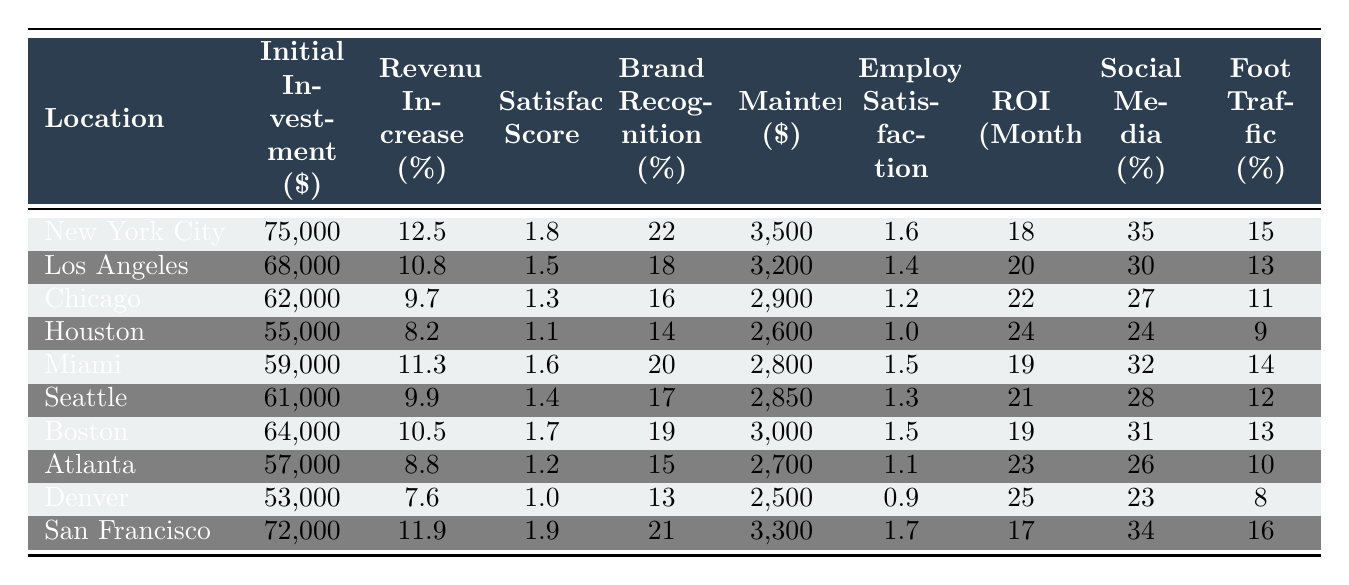What is the initial investment for the store in Miami? The initial investment for Miami is listed directly in the table under the "Initial Investment ($)" column. The value for Miami is 59,000.
Answer: 59,000 Which store location has the highest brand recognition boost percentage? The "Brand Recognition Boost (%)" column shows the percentage boosts for each location. Scanning through the values, San Francisco has the highest at 21%.
Answer: 21% What is the ROI period in months for the store in Chicago? To find the ROI period for Chicago, I refer to the "ROI Period (Months)" column. The value listed for Chicago is 22 months.
Answer: 22 Is the customer satisfaction score improvement for Atlanta greater than that for Houston? Comparing the "Customer Satisfaction Score Improvement" values for Atlanta and Houston, Atlanta has a score of 1.2 and Houston has a score of 1.1. Since 1.2 is greater than 1.1, the answer is yes.
Answer: Yes What is the average annual revenue increase percentage across all locations? First, I sum the "Annual Revenue Increase (%)" values: 12.5 + 10.8 + 9.7 + 8.2 + 11.3 + 9.9 + 10.5 + 8.8 + 7.6 + 11.9 = 99.2. Since there are 10 locations, I divide 99.2 by 10, resulting in an average of 9.92%.
Answer: 9.92% Which store location has the lowest maintenance costs per year? The "Maintenance Costs per Year ($)" column needs to be checked for the minimum value. Denver has the lowest maintenance cost of 2,500.
Answer: 2,500 If we compare the employee satisfaction improvements, is there a location with an improvement greater than 1.5? Checking the "Employee Satisfaction Improvement" column, both New York City and San Francisco have improvements of 1.6 and 1.7 respectively, which are both above 1.5. Therefore, the answer is yes.
Answer: Yes What is the total increase in social media mentions for the stores in New York City and Los Angeles combined? To find the total, I add the "Social Media Mentions Increase (%)" values for New York City (35%) and Los Angeles (30%). Thus, 35 + 30 equals 65%.
Answer: 65% Which location has the highest foot traffic increase percentage? The "Foot Traffic Increase (%)" column reveals that San Francisco has the highest foot traffic increase at 16%.
Answer: 16% Is there a location where the annual revenue increase percentage is less than 9%? By reviewing the "Annual Revenue Increase (%)" column, it shows that Denver has the lowest percentage, at 7.6%, which is indeed less than 9%.
Answer: Yes 